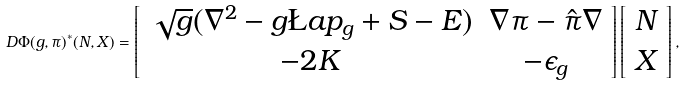Convert formula to latex. <formula><loc_0><loc_0><loc_500><loc_500>D \Phi ( g , \pi ) ^ { * } ( N , X ) = \left [ \begin{array} { c c } \sqrt { g } ( \nabla ^ { 2 } - g \L a p _ { g } + S - E ) & \nabla \pi - \hat { \pi } \nabla \\ - 2 K & - \epsilon _ { g } \end{array} \right ] \left [ \begin{array} { c } N \\ X \end{array} \right ] ,</formula> 